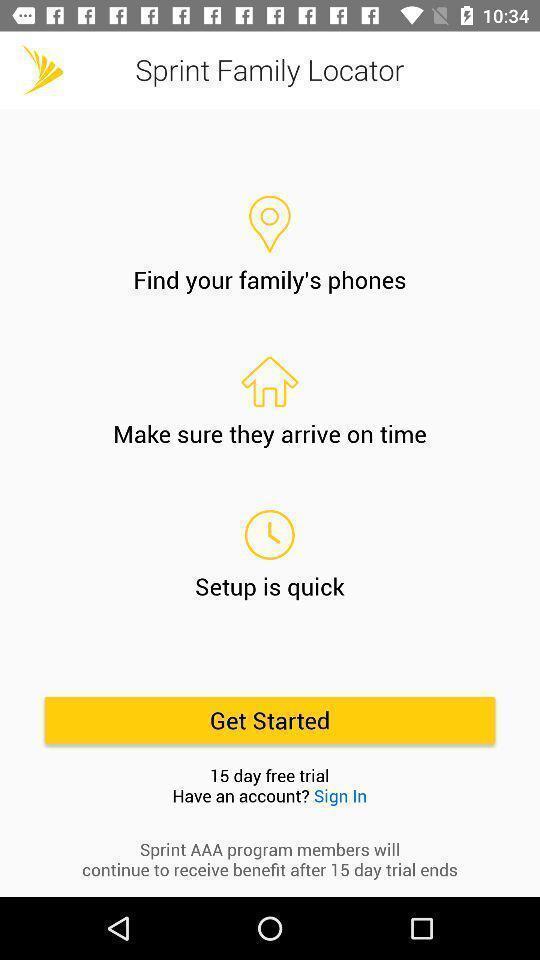Summarize the information in this screenshot. Welcome screen of family locator app. 